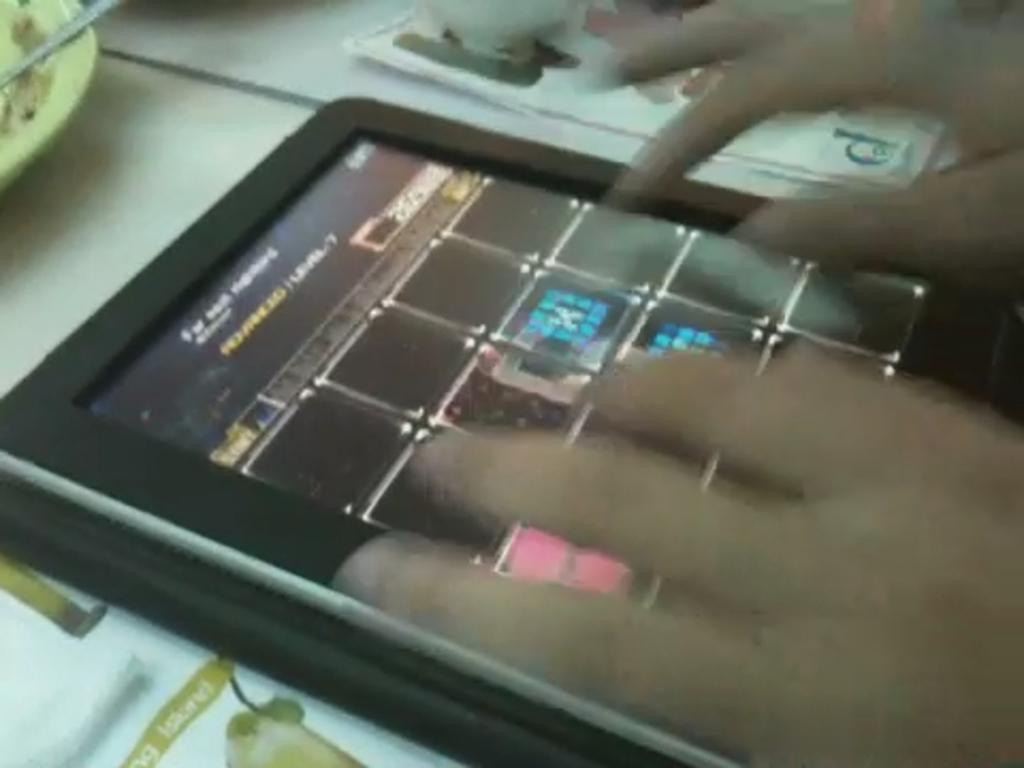What electronic device is present in the image? There is an iPad in the image. What type of paper-based items can be seen in the image? There are papers in the image. What is the color of the surface on which the objects are placed? The objects are placed on a white color surface. Whose hands are visible in the image? A person's hands are visible to the right in the image. What type of oven is visible in the image? There is no oven present in the image. Is the person in the image walking or running? The image does not show the person in motion, so it cannot be determined if they are walking or running. 